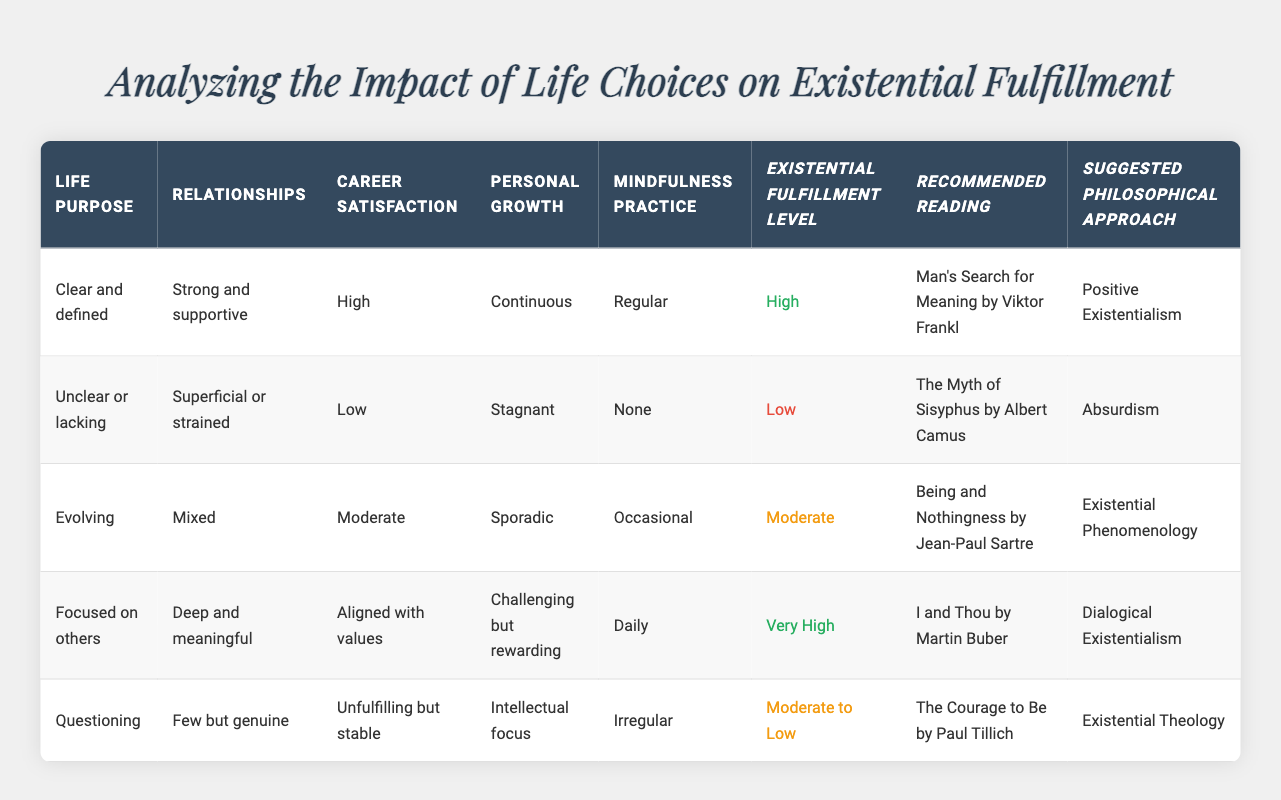What are the conditions for achieving a "Very High" level of existential fulfillment? To find the conditions for "Very High" existential fulfillment, we look for the row in the table where this level is indicated. The relevant row corresponds to having a "Focused on others" life purpose, "Deep and meaningful" relationships, "Aligned with values" career satisfaction, "Challenging but rewarding" personal growth, and "Daily" mindfulness practice.
Answer: Focused on others, Deep and meaningful, Aligned with values, Challenging but rewarding, Daily Who is the recommended author if one's existential fulfillment level is "Low"? The existential fulfillment level "Low" is found in the second rule of the table, which states the recommended reading is "The Myth of Sisyphus" by Albert Camus.
Answer: Albert Camus Is it true that high career satisfaction correlates to high existential fulfillment? To answer this, we need to look at the rows with high career satisfaction. The first row shows high career satisfaction and high fulfillment, while the fourth row also shows alignment with values leading to "Very High" fulfillment. However, the second row has low career satisfaction with low fulfillment. In conclusion, high career satisfaction does not guarantee high fulfillment.
Answer: No What is the average level of existential fulfillment when personal growth is "Sporadic"? The only row with "Sporadic" personal growth is the third row, indicating a "Moderate" level of existential fulfillment. Since there is only one data point for this condition, the average is the same as that single value.
Answer: Moderate Which recommended reading aligns with a "Questioning" life purpose, and what is its suggested philosophical approach? The row pertaining to "Questioning" life purpose indicates a recommended reading of "The Courage to Be" by Paul Tillich, and the suggested philosophical approach listed is "Existential Theology."
Answer: The Courage to Be, Existential Theology If someone practices mindfulness daily, what fulfillment level can they expect? The only row in the table for "Daily" mindfulness practice points to the fourth row, where the existential fulfillment level is "Very High." Hence, practicing mindfulness daily correlates with this high fulfillment level.
Answer: Very High 